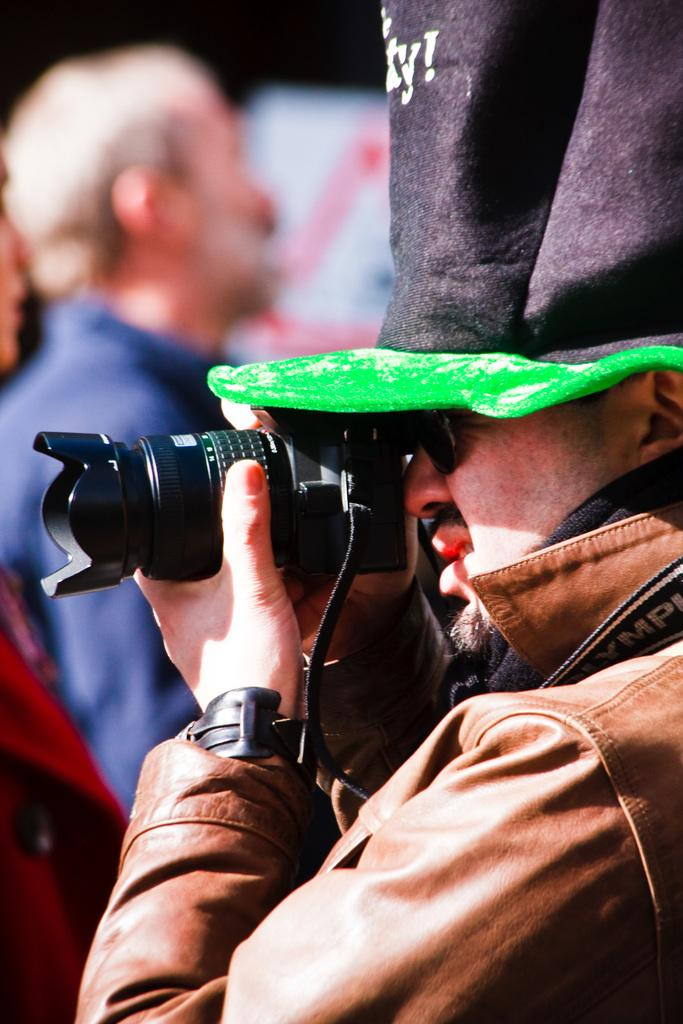What is the man in the image doing? The man is taking a picture. What is the man wearing in the image? The man is wearing a jacket and a cap. What is the man holding in his hand in the image? The man is holding a camera in his hand. Can you describe the other person in the image? There is another person in the background of the image, but they are blurry. What type of trousers is the man wearing in the image? The provided facts do not mention the type of trousers the man is wearing. Is the man in the image a crook? There is no information in the image or the provided facts to suggest that the man is a crook. 